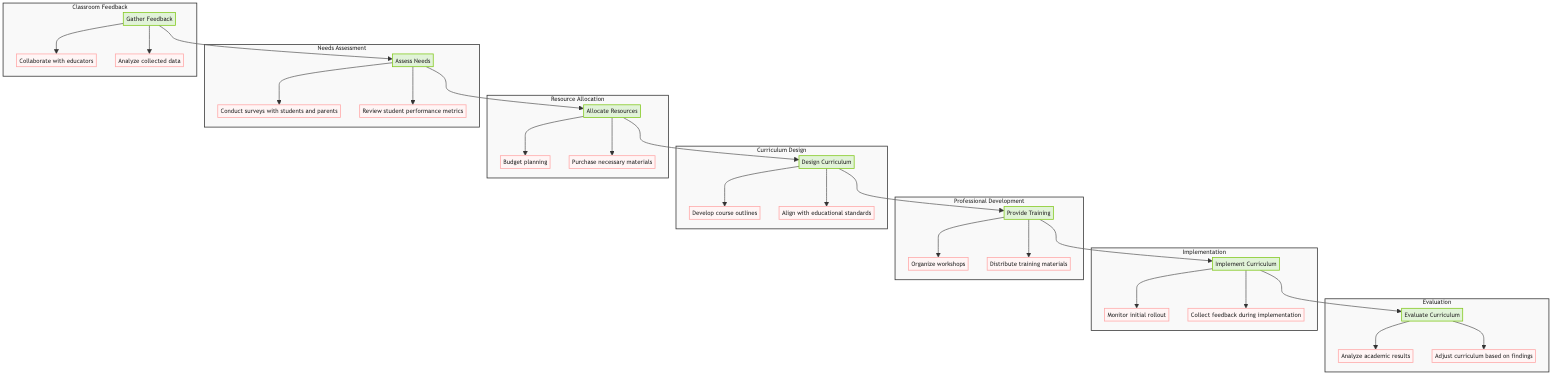What is the final process in the curriculum development flow? The diagram indicates that the last process after implementation is evaluation, represented by the node labeled 'Evaluate Curriculum.'
Answer: evaluation How many steps are included in the professional development phase? The professional development phase includes two steps: 'Organize workshops' and 'Distribute training materials.' Therefore, it has a total of two steps connected to it.
Answer: two Which step immediately follows needs assessment? The needs assessment step feeds into resource allocation. The arrow linking these nodes shows that resource allocation is the next phase in the flow.
Answer: resource allocation What are the two actions associated with classroom feedback? The diagram shows that gathering feedback involves two actions: 'Collaborate with educators' and 'Analyze collected data.' These actions are the direct next steps after the classroom feedback process.
Answer: collaborate with educators, analyze collected data What is the main objective of the needs assessment process? The needs assessment aims to identify gaps in the current curriculum through methods such as surveys and assessments, as described in the node's description.
Answer: identify gaps in the current curriculum What are the components of the implementation phase? The implementation phase includes two components: 'Monitor initial rollout' and 'Collect feedback during implementation.' Thus, it involves monitoring and collecting feedback.
Answer: monitor initial rollout, collect feedback during implementation What is the starting point of the curriculum development process? The flow chart begins with the classroom feedback process, which gathers input from teachers, indicated by the starting node.
Answer: classroom feedback How are the steps organized in the diagram? The steps in the diagram are arranged in a bottom-up fashion, where classroom feedback starts the process, leading through needs assessment, resource allocation, curriculum design, professional development, implementation, and ending with evaluation. This organization is characteristic of how the flow transitions from collection to evaluation.
Answer: bottom-up fashion 